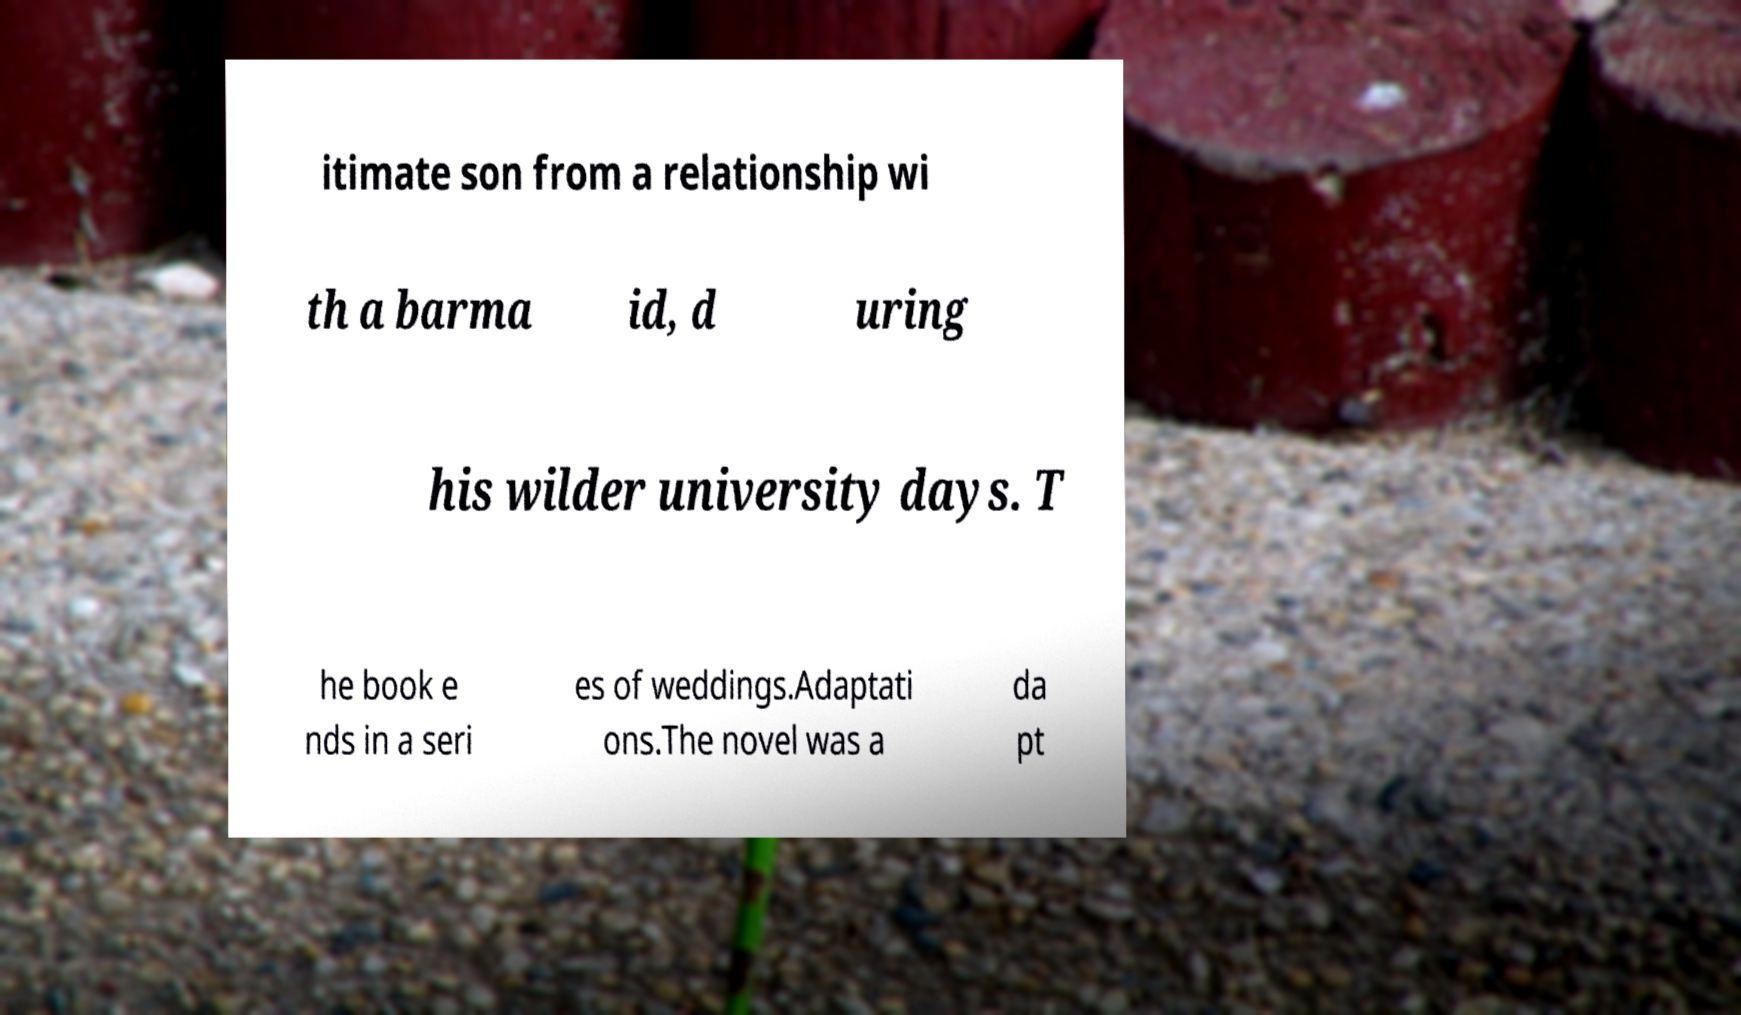I need the written content from this picture converted into text. Can you do that? itimate son from a relationship wi th a barma id, d uring his wilder university days. T he book e nds in a seri es of weddings.Adaptati ons.The novel was a da pt 